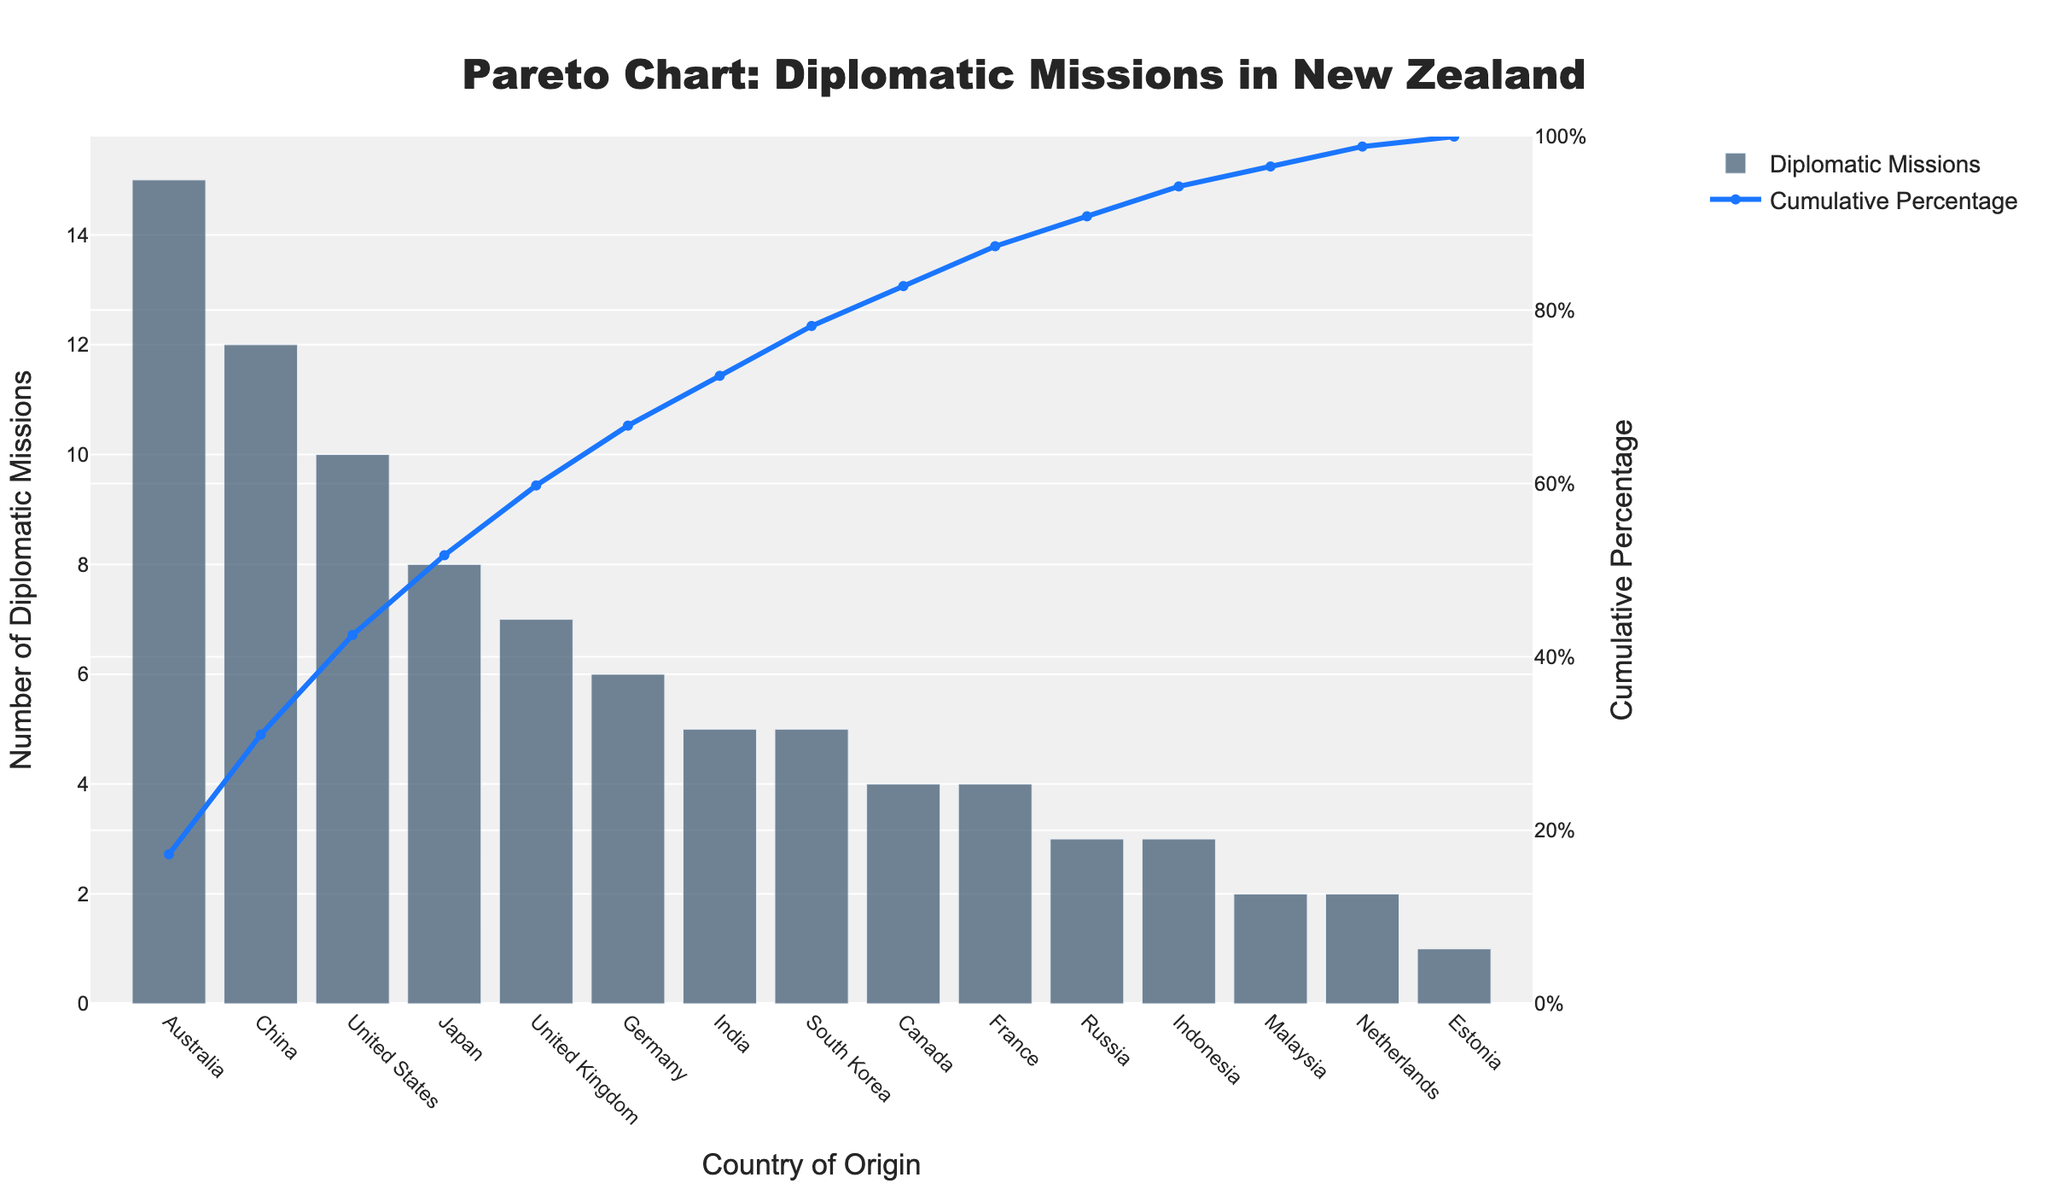What is the title of the chart? The title can be found at the top of the chart in a larger font size, centered. It reads: "Pareto Chart: Diplomatic Missions in New Zealand".
Answer: Pareto Chart: Diplomatic Missions in New Zealand Which country has the highest number of diplomatic missions in New Zealand? The bar representing the highest value corresponds to Australia. This can be seen as the tallest bar in the chart.
Answer: Australia What is the cumulative percentage of diplomatic missions for the top 3 countries? Add the number of diplomatic missions for Australia (15), China (12), and United States (10), which totals 37. Calculate the cumulative percentage: (37/89) * 100 ≈ 41.57%. This is also shown in the line chart for the third data point.
Answer: 41.57% How many diplomatic missions does Estonia have in New Zealand? Look for the bar corresponding to Estonia, which is the smallest bar near the end of the chart. The number is displayed as 1.
Answer: 1 What is the cumulative percentage after including the United Kingdom? Sum the number of diplomatic missions for Australia (15), China (12), United States (10), and United Kingdom (7). This totals 44. Calculate the cumulative percentage: (44/89) * 100 ≈ 49.44%. The line chart for the fourth data point validates this.
Answer: 49.44% Which country lies just below the cumulative percentage threshold of 50%? The cumulative percentage reaches approximately 49.44% with the addition of the United Kingdom. Hence, the United Kingdom lies just below the 50% threshold.
Answer: United Kingdom What is the number of diplomatic missions for countries that have exactly 5 missions each? Identify the countries with 5 missions from the bars, which are India and South Korea.
Answer: 2 countries (India and South Korea) What percentage of the total diplomatic missions is represented by the top 5 countries? Sum the diplomatic missions for the top 5 countries: Australia (15), China (12), United States (10), Japan (8), and United Kingdom (7). This totals 52. Calculate the percentage: (52/89) * 100 ≈ 58.43%.
Answer: 58.43% How does the cumulative percentage change as you go from Germany to India? The bar for Germany adds 6 missions, making the cumulative percentage around 66.29%. Adding India introduces 5 more missions, bringing the total to 72.47%. The line chart confirms this gradual increase.
Answer: From 66.29% to 72.47% Which countries contribute to reaching the 80% cumulative percentage mark? Calculate iteratively: Australia (15), China (12), United States (10), Japan (8), United Kingdom (7), Germany (6), India (5), and South Korea (5). The cumulative percentage sums to 88.76%, indicating the mentioned countries contribute up to this point.
Answer: Australia, China, United States, Japan, United Kingdom, Germany, India, South Korea 